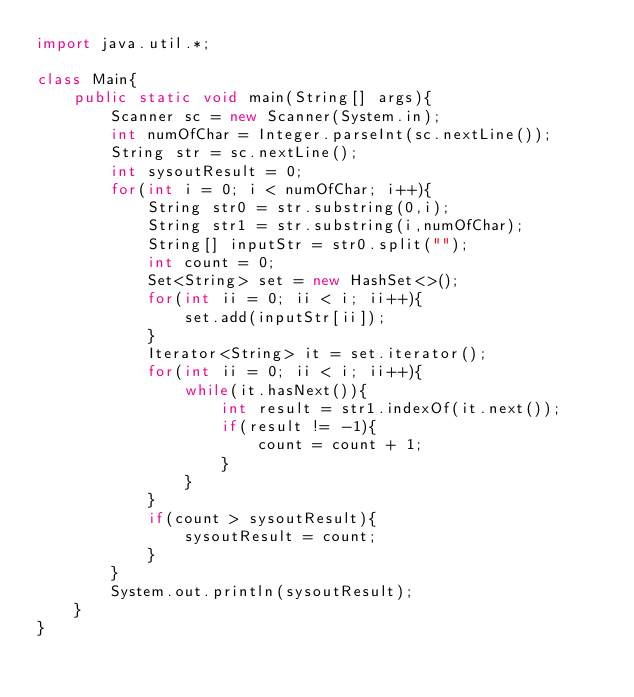Convert code to text. <code><loc_0><loc_0><loc_500><loc_500><_Java_>import java.util.*;

class Main{
	public static void main(String[] args){
		Scanner sc = new Scanner(System.in);
		int numOfChar = Integer.parseInt(sc.nextLine());
		String str = sc.nextLine();
		int sysoutResult = 0;
		for(int i = 0; i < numOfChar; i++){
			String str0 = str.substring(0,i);
			String str1 = str.substring(i,numOfChar);
			String[] inputStr = str0.split("");
			int count = 0;
			Set<String> set = new HashSet<>();
			for(int ii = 0; ii < i; ii++){
				set.add(inputStr[ii]);
			}
			Iterator<String> it = set.iterator();
			for(int ii = 0; ii < i; ii++){
				while(it.hasNext()){
					int result = str1.indexOf(it.next());
					if(result != -1){
						count = count + 1;
					}
				}
			}
			if(count > sysoutResult){
				sysoutResult = count;
			}
		}
		System.out.println(sysoutResult);
	}
}</code> 